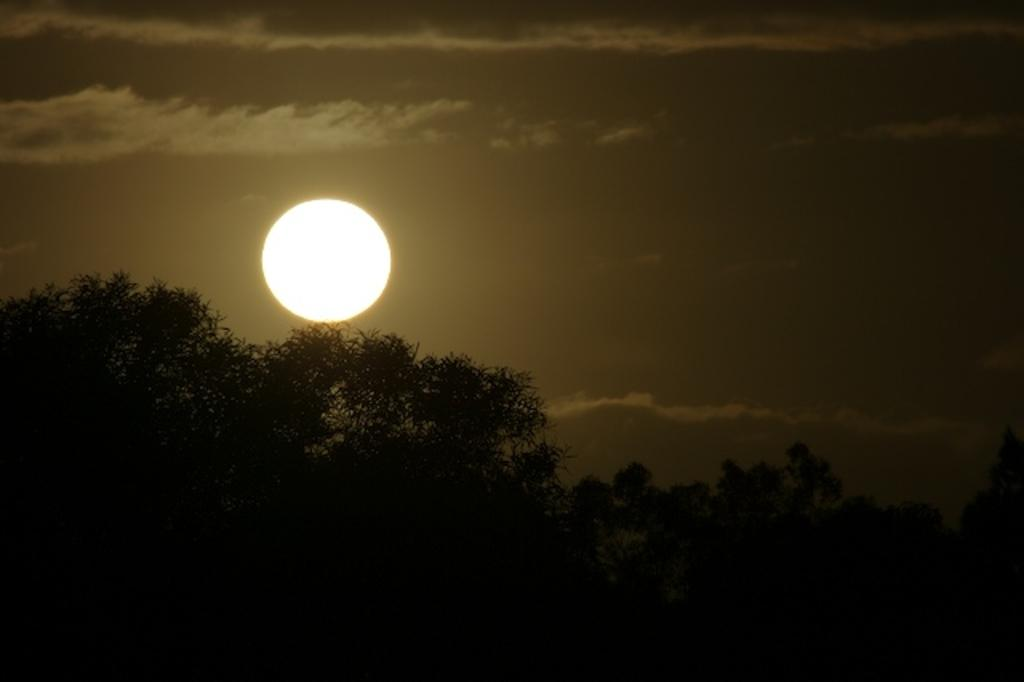What celestial body is visible in the sky in the image? The sun is visible in the sky in the image. What else can be seen in the sky in the image? There are clouds in the sky in the image. What type of vegetation is visible at the bottom of the image? There are trees visible at the bottom of the image. What type of grain can be seen being transported in a pail in the image? There is no grain or pail present in the image. Is there anyone driving a vehicle in the image? There is no vehicle or driving activity present in the image. 